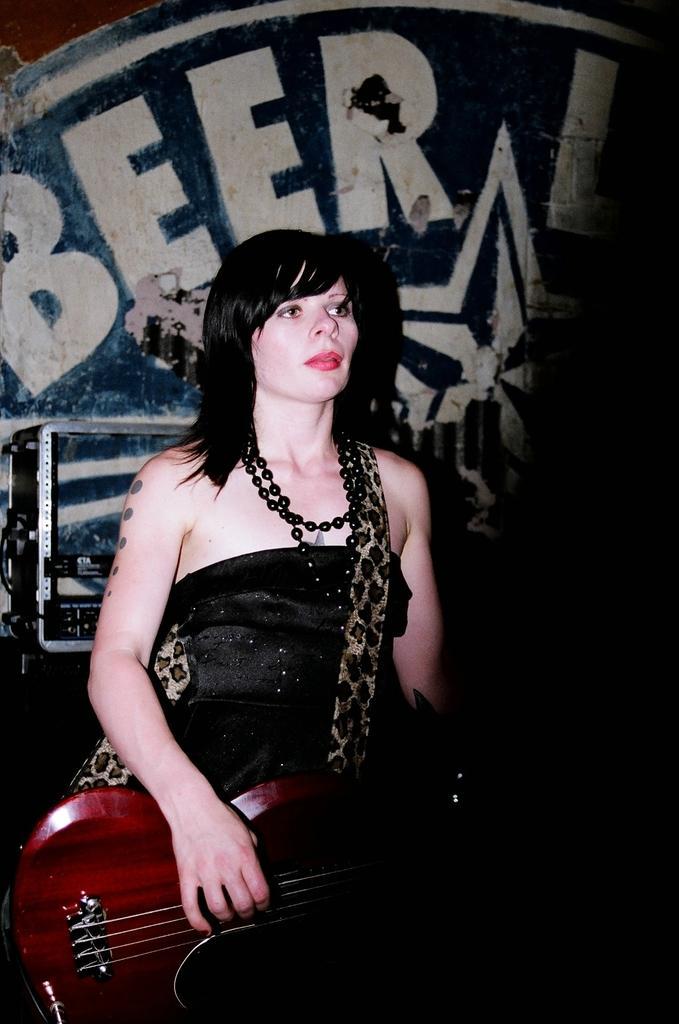Could you give a brief overview of what you see in this image? In this image i can see a woman is playing a guitar. 